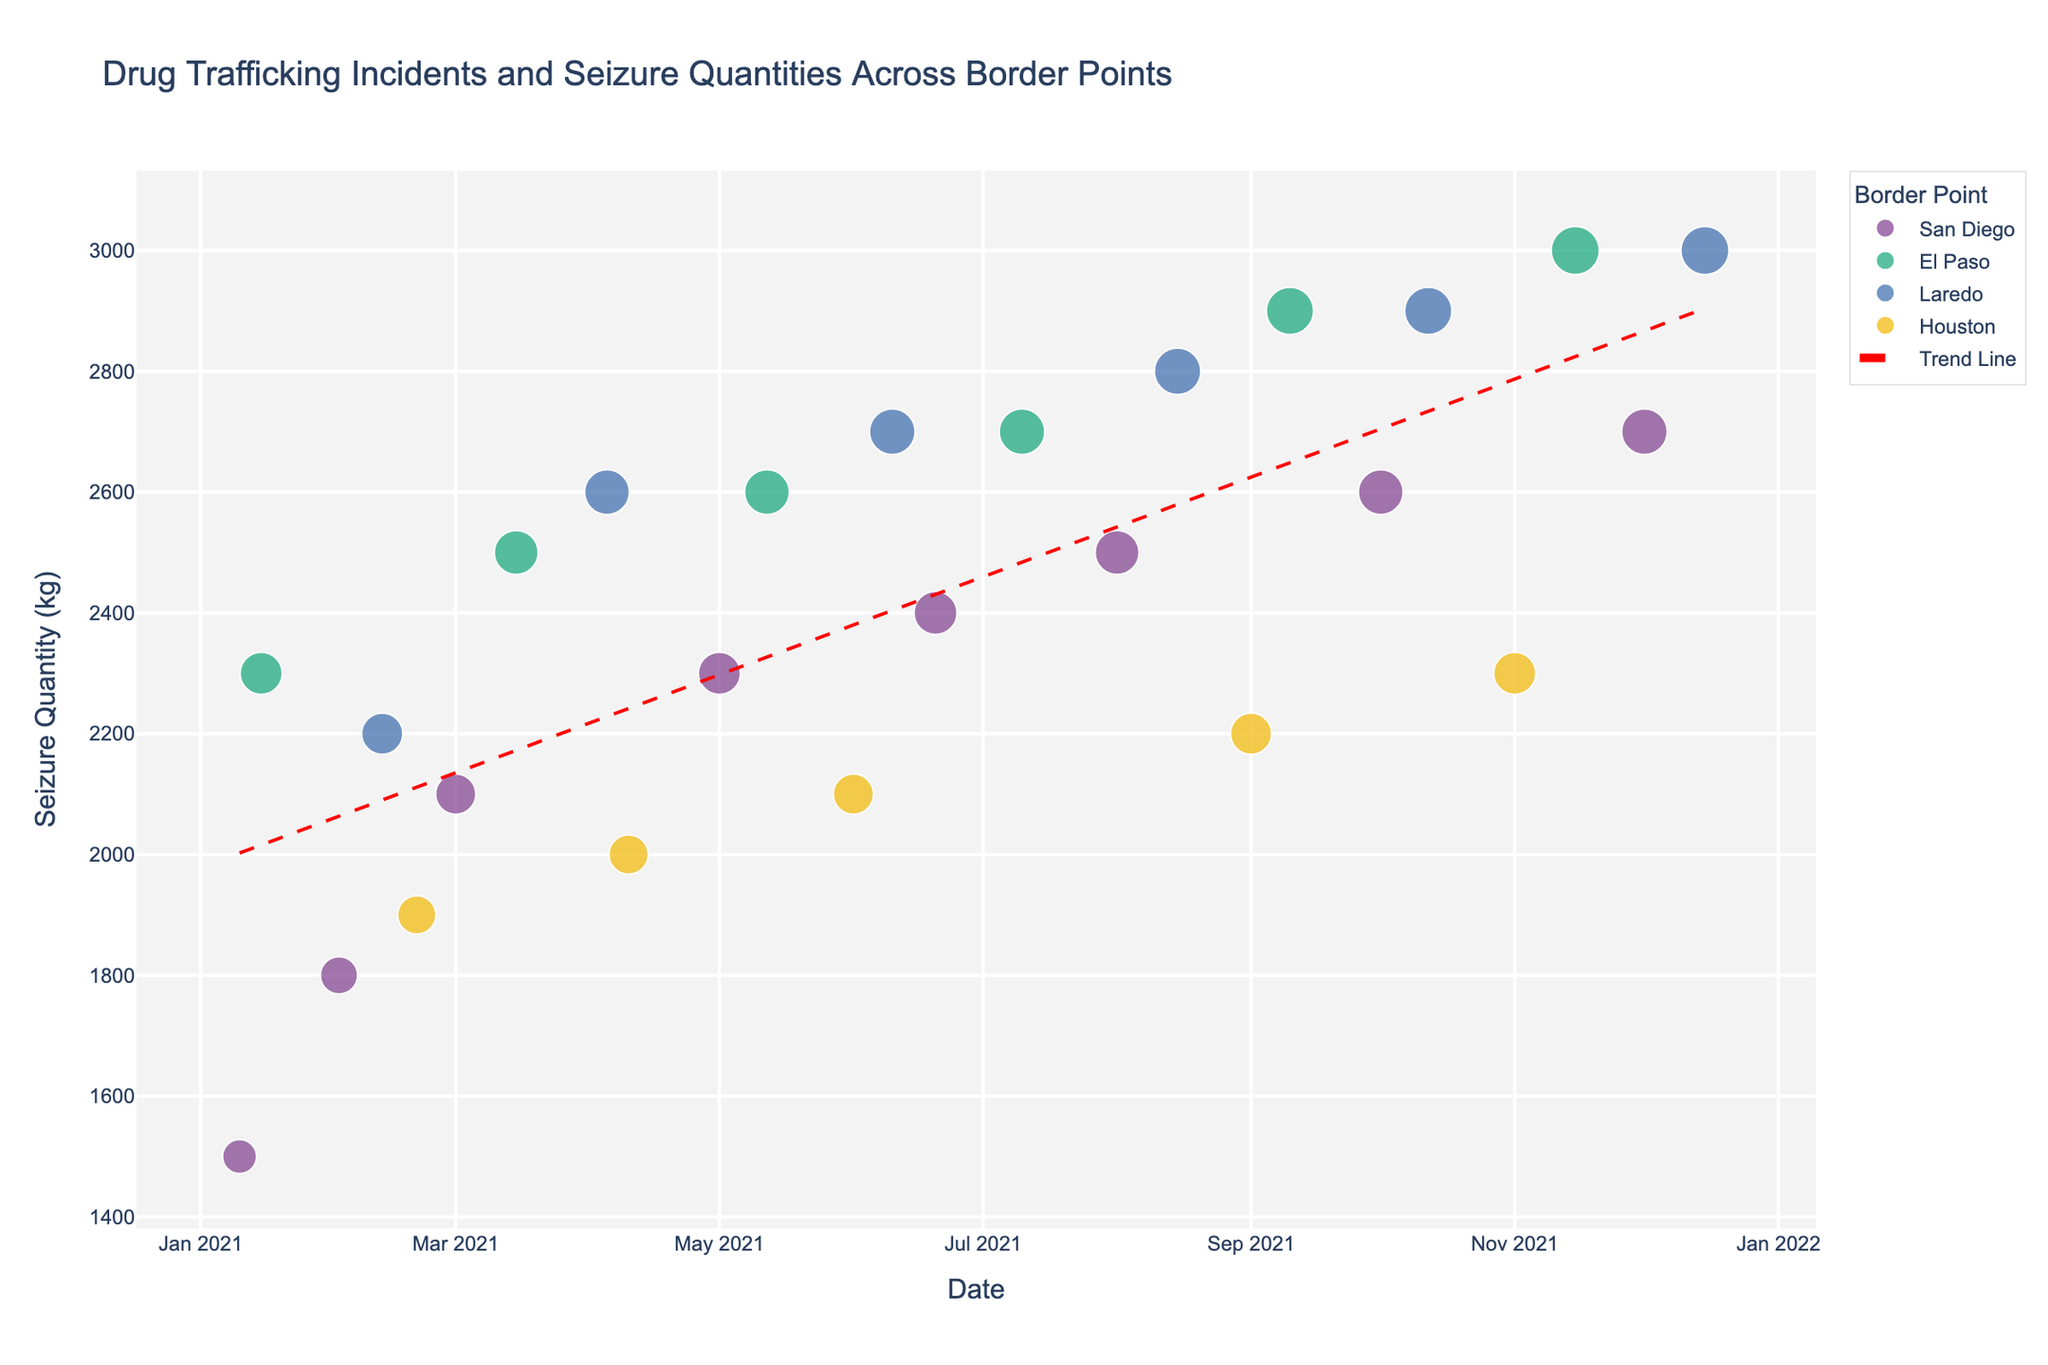What is the title of the scatter plot? The title of the scatter plot is displayed at the top center of the figure. It indicates the main subject of the data being visualized.
Answer: Drug Trafficking Incidents and Seizure Quantities Across Border Points How many border points are represented in the figure? The border points are differentiated by color and listed in the legend on the right side of the plot. Counting the unique border points in the legend will give the answer.
Answer: Four Which border point has the highest seizure quantity in the dataset? Look for the largest data point within each border point category and then compare the highest values among them.
Answer: El Paso On what date was the highest seizure quantity recorded? Identify the largest data point in the plot and then read the corresponding date on the x-axis under that point.
Answer: 2021-12-15 What is the trend in seizure quantities over time according to the trend line? Observe the slope of the trend line added to the scatter plot. If the line slopes upward from left to right, the trend is increasing; if it slopes downward, the trend is decreasing.
Answer: Increasing Which month in 2021 saw the highest combined seizure quantity across all border points? Identify the data points for each month and sum the seizure quantities for each month. Compare the total quantities to find the month with the highest combined quantity.
Answer: December How many seizure incidents were recorded in San Diego? Count the number of data points specifically representing San Diego, which can be identified by their color as shown in the legend.
Answer: Six What is the difference in seizure quantity between San Diego and Laredo over the year? Sum the quantities for all incidents in San Diego and Laredo separately, then calculate the difference between these two sums.
Answer: San Diego: 15,800 kg; Laredo: 17,400 kg; Difference: 1,600 kg Compare the seizure quantities of El Paso and Houston in June 2021. Which one is higher and by how much? Find the data points for El Paso and Houston in June 2021 by checking the dates and compare their quantities. Subtract the smaller quantity from the larger quantity.
Answer: El Paso has 2,600 kg; Houston has 2,100 kg; Difference: 500 kg What is the average seizure quantity across all border points? Sum all the seizure quantities from the data points and divide by the total number of incidents to find the average.
Answer: Total seizure quantity: 59,400 kg; Total incidents: 24; Average: 2,475 kg 